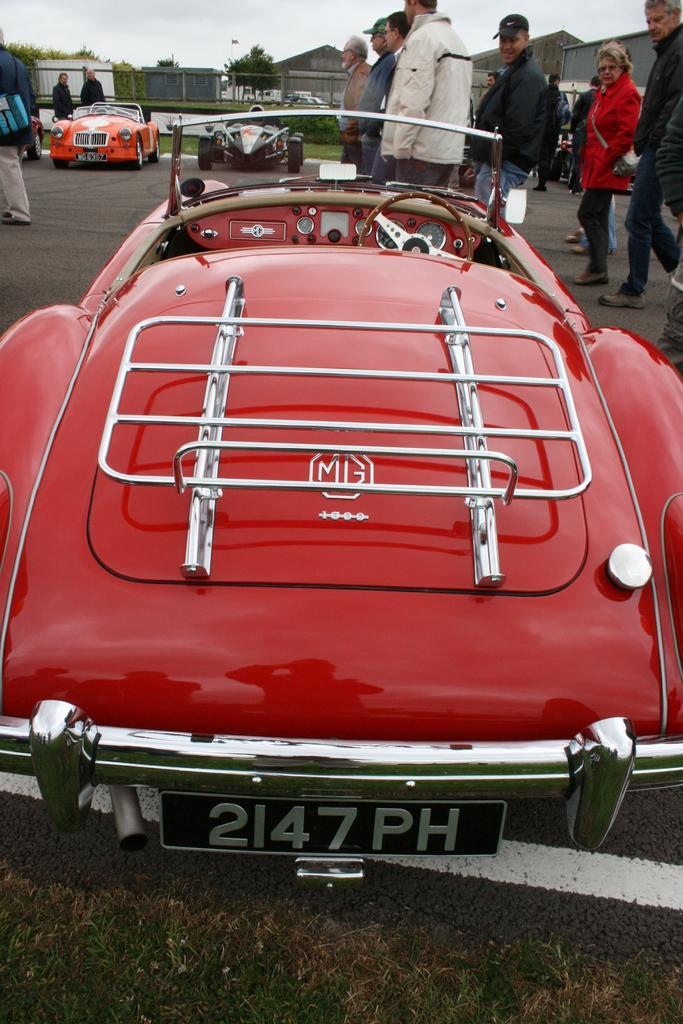In one or two sentences, can you explain what this image depicts? This image consists of a car in red color. At the bottom, there is road and grass. In the background, there are two more cars. There are many people in this image. At the top, there is sky. In the front, we can see the houses. 